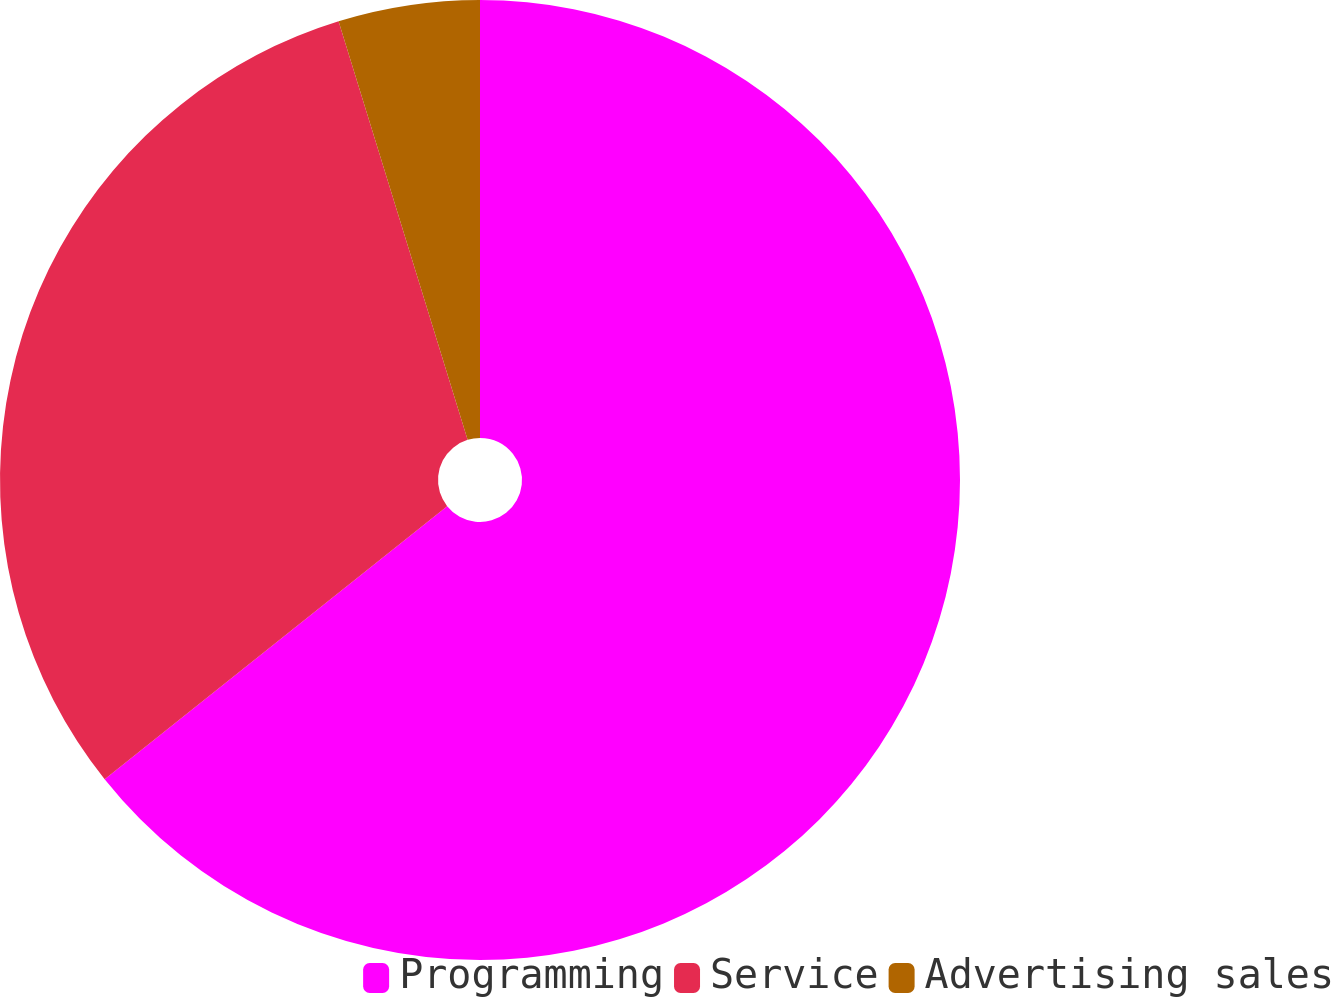Convert chart. <chart><loc_0><loc_0><loc_500><loc_500><pie_chart><fcel>Programming<fcel>Service<fcel>Advertising sales<nl><fcel>64.29%<fcel>30.95%<fcel>4.76%<nl></chart> 